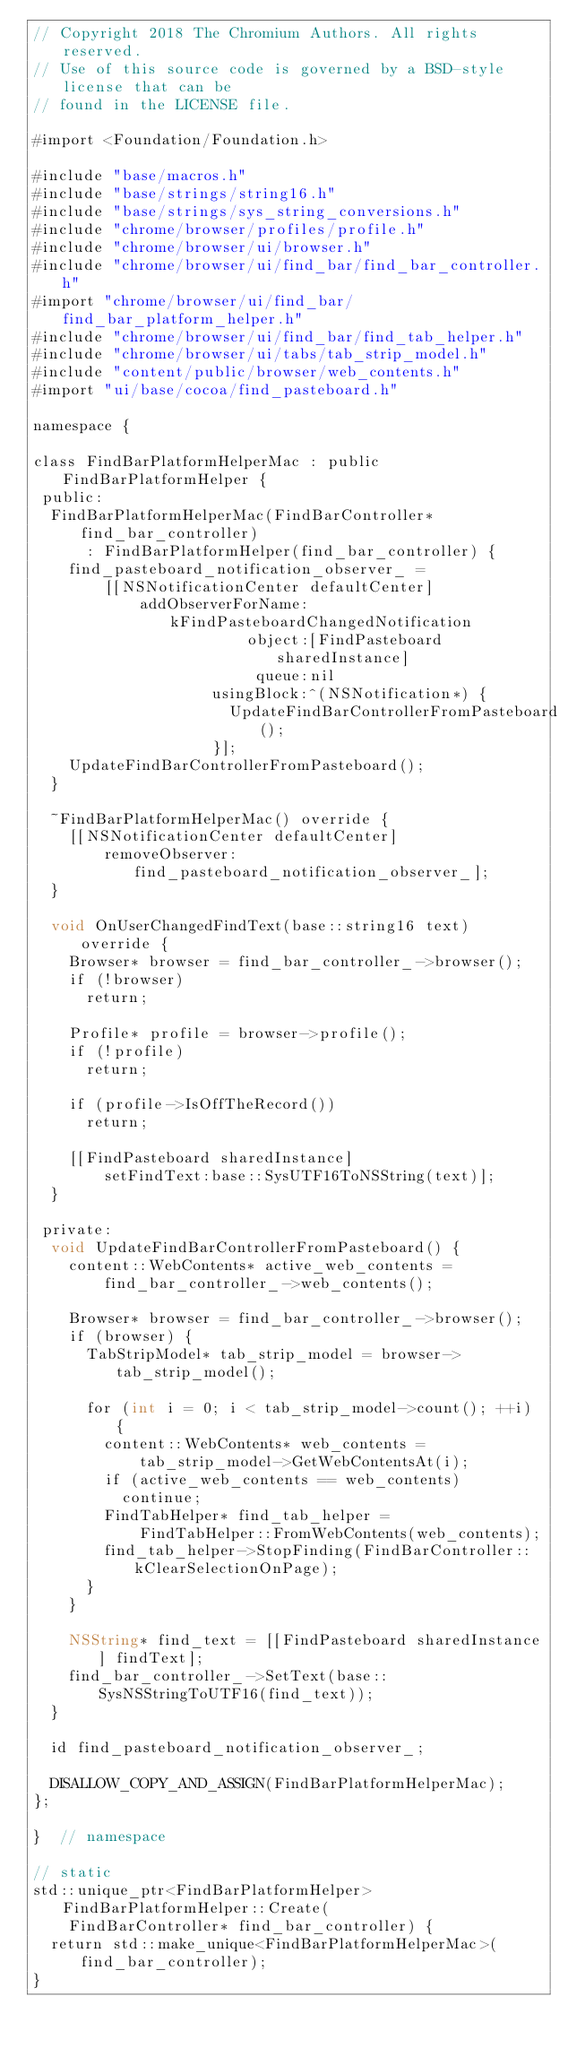<code> <loc_0><loc_0><loc_500><loc_500><_ObjectiveC_>// Copyright 2018 The Chromium Authors. All rights reserved.
// Use of this source code is governed by a BSD-style license that can be
// found in the LICENSE file.

#import <Foundation/Foundation.h>

#include "base/macros.h"
#include "base/strings/string16.h"
#include "base/strings/sys_string_conversions.h"
#include "chrome/browser/profiles/profile.h"
#include "chrome/browser/ui/browser.h"
#include "chrome/browser/ui/find_bar/find_bar_controller.h"
#import "chrome/browser/ui/find_bar/find_bar_platform_helper.h"
#include "chrome/browser/ui/find_bar/find_tab_helper.h"
#include "chrome/browser/ui/tabs/tab_strip_model.h"
#include "content/public/browser/web_contents.h"
#import "ui/base/cocoa/find_pasteboard.h"

namespace {

class FindBarPlatformHelperMac : public FindBarPlatformHelper {
 public:
  FindBarPlatformHelperMac(FindBarController* find_bar_controller)
      : FindBarPlatformHelper(find_bar_controller) {
    find_pasteboard_notification_observer_ =
        [[NSNotificationCenter defaultCenter]
            addObserverForName:kFindPasteboardChangedNotification
                        object:[FindPasteboard sharedInstance]
                         queue:nil
                    usingBlock:^(NSNotification*) {
                      UpdateFindBarControllerFromPasteboard();
                    }];
    UpdateFindBarControllerFromPasteboard();
  }

  ~FindBarPlatformHelperMac() override {
    [[NSNotificationCenter defaultCenter]
        removeObserver:find_pasteboard_notification_observer_];
  }

  void OnUserChangedFindText(base::string16 text) override {
    Browser* browser = find_bar_controller_->browser();
    if (!browser)
      return;

    Profile* profile = browser->profile();
    if (!profile)
      return;

    if (profile->IsOffTheRecord())
      return;

    [[FindPasteboard sharedInstance]
        setFindText:base::SysUTF16ToNSString(text)];
  }

 private:
  void UpdateFindBarControllerFromPasteboard() {
    content::WebContents* active_web_contents =
        find_bar_controller_->web_contents();

    Browser* browser = find_bar_controller_->browser();
    if (browser) {
      TabStripModel* tab_strip_model = browser->tab_strip_model();

      for (int i = 0; i < tab_strip_model->count(); ++i) {
        content::WebContents* web_contents =
            tab_strip_model->GetWebContentsAt(i);
        if (active_web_contents == web_contents)
          continue;
        FindTabHelper* find_tab_helper =
            FindTabHelper::FromWebContents(web_contents);
        find_tab_helper->StopFinding(FindBarController::kClearSelectionOnPage);
      }
    }

    NSString* find_text = [[FindPasteboard sharedInstance] findText];
    find_bar_controller_->SetText(base::SysNSStringToUTF16(find_text));
  }

  id find_pasteboard_notification_observer_;

  DISALLOW_COPY_AND_ASSIGN(FindBarPlatformHelperMac);
};

}  // namespace

// static
std::unique_ptr<FindBarPlatformHelper> FindBarPlatformHelper::Create(
    FindBarController* find_bar_controller) {
  return std::make_unique<FindBarPlatformHelperMac>(find_bar_controller);
}
</code> 